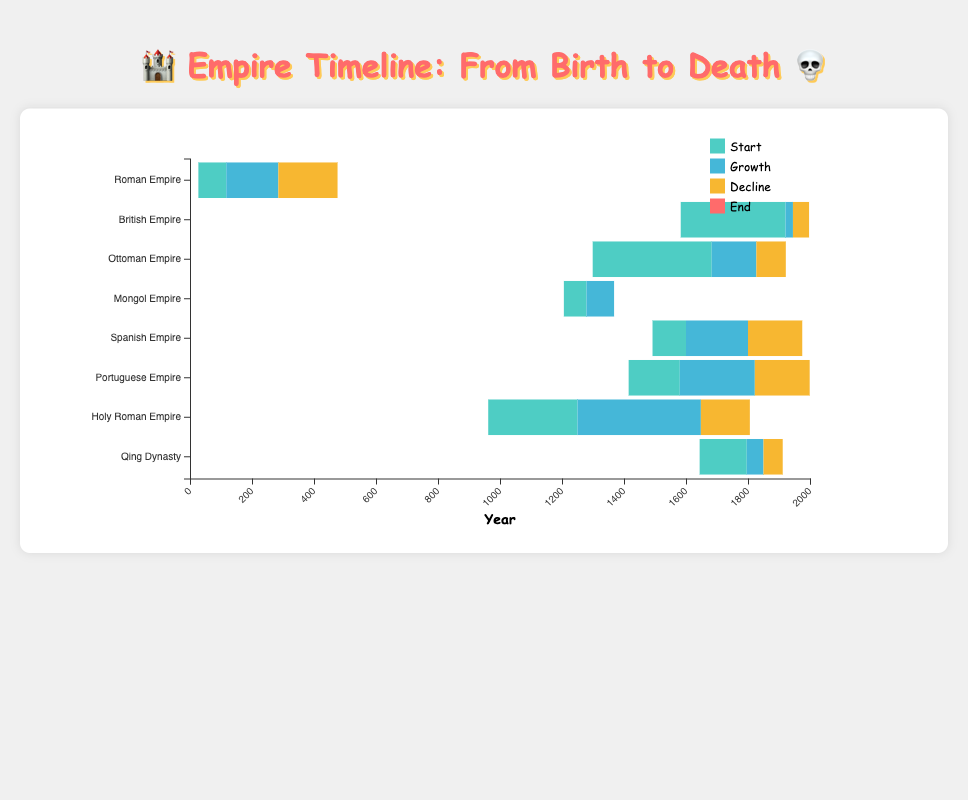What is the start year of the British Empire? The start year of each empire is visually indicated by the position of the left edge of the first segment of each bar. For the British Empire, the leftmost segment begins at 1583.
Answer: 1583 Which empire lasted the longest overall? Calculate the overall duration by subtracting the start year from the end year for each empire. The empire with the longest duration is the British Empire, which lasted from 1583 to 1997, a total of 414 years.
Answer: British Empire Which empire had its peak period the latest? The peak period is highlighted by the second segment of each bar, which starts at different points in time. Comparing these points, the British Empire reached its peak latest, in 1921.
Answer: British Empire Compare the decline duration of the Roman Empire and the Ottoman Empire. Which one had a longer decline period? The decline period is indicated by the third segment of each bar. To find each decline's length, subtract the peak year from the end year for both empires. For the Roman Empire: 476 - 285 = 191 years. For the Ottoman Empire: 1922 - 1827 = 95 years. The Roman Empire had a longer decline period.
Answer: Roman Empire How many empires peaked after the year 1600? Find the peak years from the second segment of the bars and count those greater than 1600. The British Empire (1921), the Ottoman Empire (1683), the Spanish Empire (1600), and the Portuguese Empire (1580) all peaked after the year 1600.
Answer: Four empires What are the colors used to represent the start, growth, decline, and end periods of the empires? The colors of the segments are visually distinct. Look at the legend or the segment colors next to each empire:
- Start: Green
- Growth: Blue
- Decline: Yellow
- End: Red
Answer: Green, Blue, Yellow, Red What is the time interval between the starting year and the peak year of the Holy Roman Empire? Check the first to the second segment of the Holy Roman Empire bar. The start year is 962, and the peak year is 1250. The interval is calculated as 1250 - 962 = 288 years.
Answer: 288 years Among the listed empires, which one started the earliest, and which one ended the most recent? The earliest start and most recent end can be found by looking at the earliest and latest points on the x-axis for the first and last segments of each bar. The earliest starting empire is the Roman Empire (27), and the most recently ending empire is the Portuguese Empire (1999).
Answer: Roman Empire, Portuguese Empire 